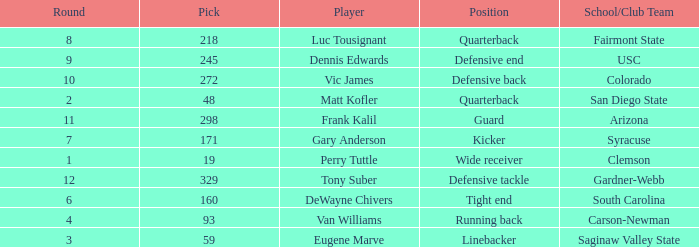Which Round has a School/Club Team of arizona, and a Pick smaller than 298? None. 